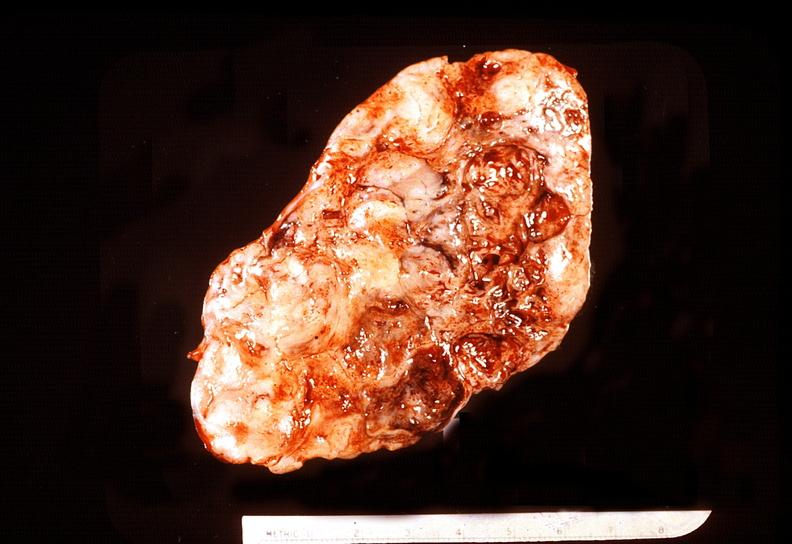does adenoma show adrenal phaeochromocytoma?
Answer the question using a single word or phrase. No 